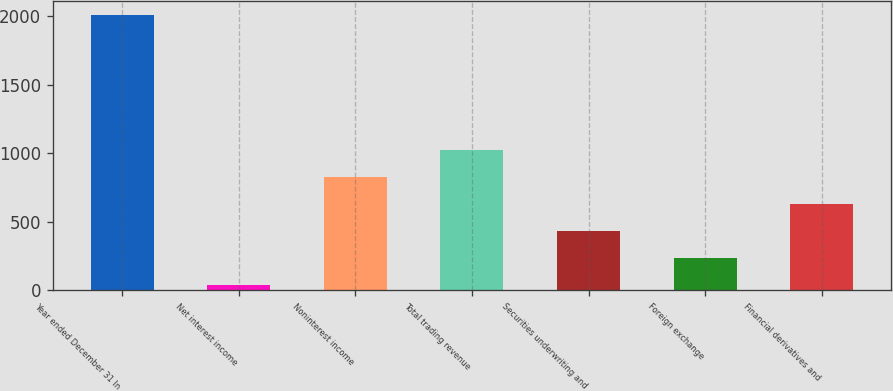<chart> <loc_0><loc_0><loc_500><loc_500><bar_chart><fcel>Year ended December 31 In<fcel>Net interest income<fcel>Noninterest income<fcel>Total trading revenue<fcel>Securities underwriting and<fcel>Foreign exchange<fcel>Financial derivatives and<nl><fcel>2012<fcel>38<fcel>827.6<fcel>1025<fcel>432.8<fcel>235.4<fcel>630.2<nl></chart> 